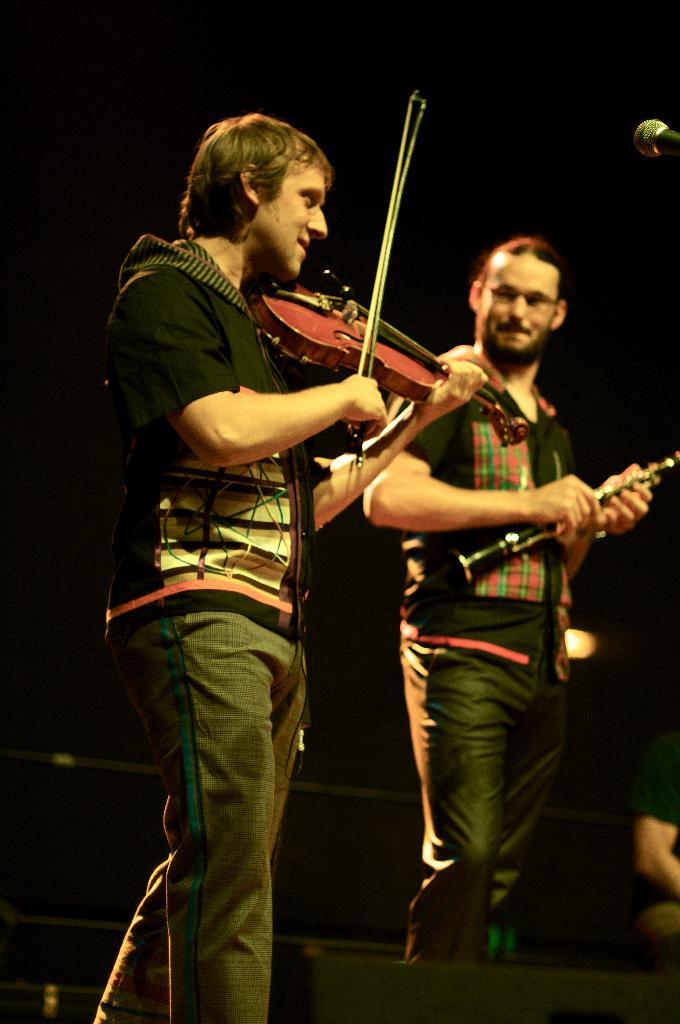How many people are in the image? There are two persons in the image. What are the persons in the image doing? Both persons are playing musical instruments. What direction are the persons in the image pointing towards? There is no indication in the image that the persons are pointing in any specific direction. 